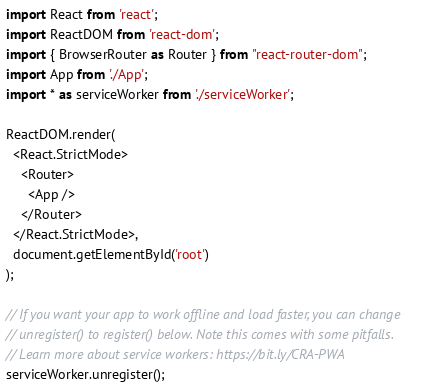<code> <loc_0><loc_0><loc_500><loc_500><_JavaScript_>import React from 'react';
import ReactDOM from 'react-dom';
import { BrowserRouter as Router } from "react-router-dom";
import App from './App';
import * as serviceWorker from './serviceWorker';

ReactDOM.render(
  <React.StrictMode>
    <Router>
      <App />
    </Router>
  </React.StrictMode>,
  document.getElementById('root')
);

// If you want your app to work offline and load faster, you can change
// unregister() to register() below. Note this comes with some pitfalls.
// Learn more about service workers: https://bit.ly/CRA-PWA
serviceWorker.unregister();
</code> 